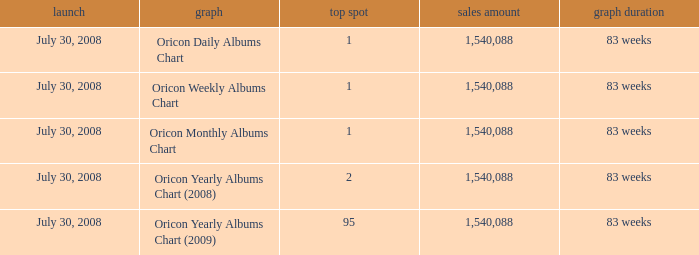Could you parse the entire table as a dict? {'header': ['launch', 'graph', 'top spot', 'sales amount', 'graph duration'], 'rows': [['July 30, 2008', 'Oricon Daily Albums Chart', '1', '1,540,088', '83 weeks'], ['July 30, 2008', 'Oricon Weekly Albums Chart', '1', '1,540,088', '83 weeks'], ['July 30, 2008', 'Oricon Monthly Albums Chart', '1', '1,540,088', '83 weeks'], ['July 30, 2008', 'Oricon Yearly Albums Chart (2008)', '2', '1,540,088', '83 weeks'], ['July 30, 2008', 'Oricon Yearly Albums Chart (2009)', '95', '1,540,088', '83 weeks']]} Which Sales Total has a Chart of oricon monthly albums chart? 1540088.0. 